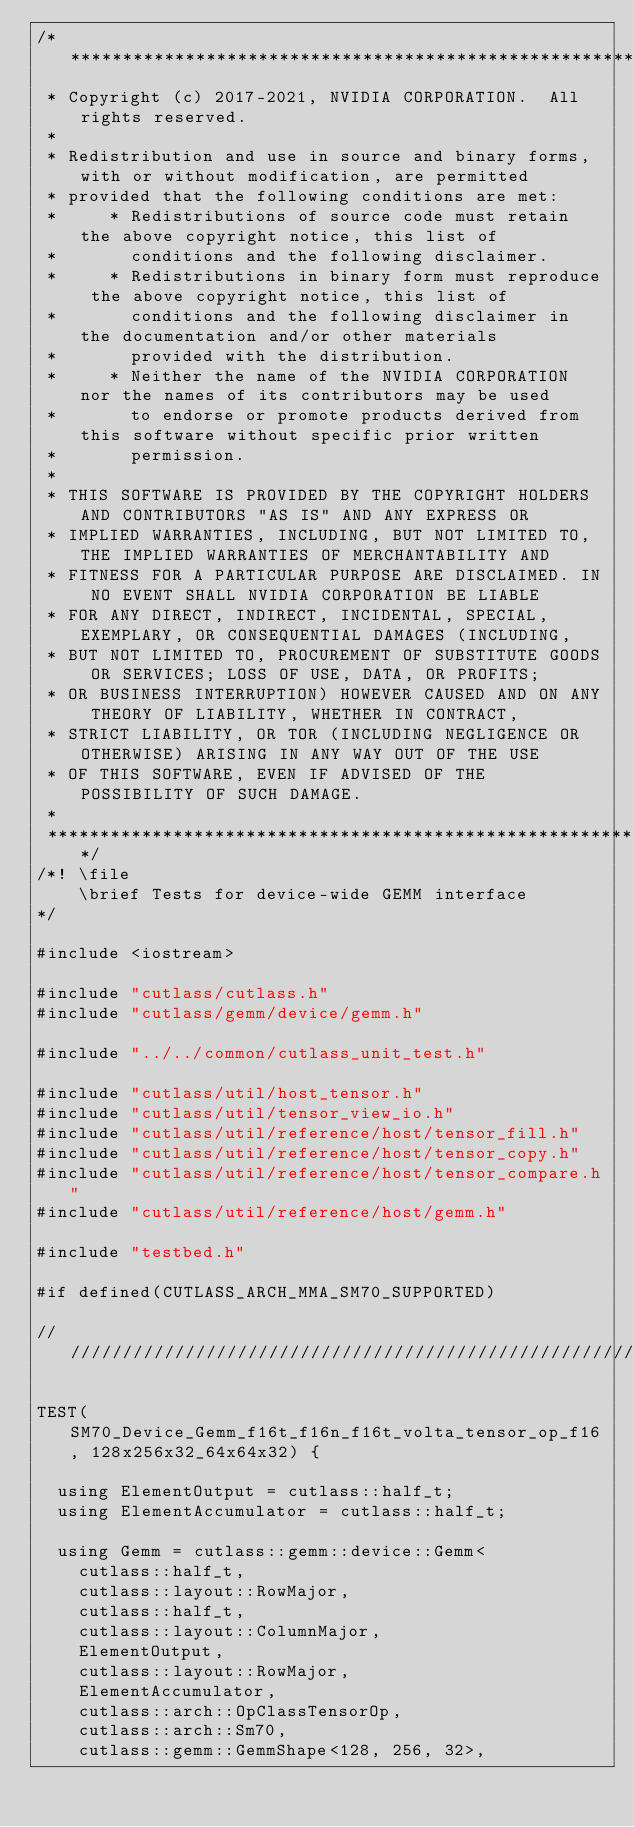<code> <loc_0><loc_0><loc_500><loc_500><_Cuda_>/***************************************************************************************************
 * Copyright (c) 2017-2021, NVIDIA CORPORATION.  All rights reserved.
 *
 * Redistribution and use in source and binary forms, with or without modification, are permitted
 * provided that the following conditions are met:
 *     * Redistributions of source code must retain the above copyright notice, this list of
 *       conditions and the following disclaimer.
 *     * Redistributions in binary form must reproduce the above copyright notice, this list of
 *       conditions and the following disclaimer in the documentation and/or other materials
 *       provided with the distribution.
 *     * Neither the name of the NVIDIA CORPORATION nor the names of its contributors may be used
 *       to endorse or promote products derived from this software without specific prior written
 *       permission.
 *
 * THIS SOFTWARE IS PROVIDED BY THE COPYRIGHT HOLDERS AND CONTRIBUTORS "AS IS" AND ANY EXPRESS OR
 * IMPLIED WARRANTIES, INCLUDING, BUT NOT LIMITED TO, THE IMPLIED WARRANTIES OF MERCHANTABILITY AND
 * FITNESS FOR A PARTICULAR PURPOSE ARE DISCLAIMED. IN NO EVENT SHALL NVIDIA CORPORATION BE LIABLE
 * FOR ANY DIRECT, INDIRECT, INCIDENTAL, SPECIAL, EXEMPLARY, OR CONSEQUENTIAL DAMAGES (INCLUDING,
 * BUT NOT LIMITED TO, PROCUREMENT OF SUBSTITUTE GOODS OR SERVICES; LOSS OF USE, DATA, OR PROFITS;
 * OR BUSINESS INTERRUPTION) HOWEVER CAUSED AND ON ANY THEORY OF LIABILITY, WHETHER IN CONTRACT,
 * STRICT LIABILITY, OR TOR (INCLUDING NEGLIGENCE OR OTHERWISE) ARISING IN ANY WAY OUT OF THE USE
 * OF THIS SOFTWARE, EVEN IF ADVISED OF THE POSSIBILITY OF SUCH DAMAGE.
 *
 **************************************************************************************************/
/*! \file
    \brief Tests for device-wide GEMM interface
*/

#include <iostream>

#include "cutlass/cutlass.h"
#include "cutlass/gemm/device/gemm.h"

#include "../../common/cutlass_unit_test.h"

#include "cutlass/util/host_tensor.h"
#include "cutlass/util/tensor_view_io.h"
#include "cutlass/util/reference/host/tensor_fill.h"
#include "cutlass/util/reference/host/tensor_copy.h"
#include "cutlass/util/reference/host/tensor_compare.h"
#include "cutlass/util/reference/host/gemm.h"

#include "testbed.h"

#if defined(CUTLASS_ARCH_MMA_SM70_SUPPORTED)

/////////////////////////////////////////////////////////////////////////////////////////////////

TEST(SM70_Device_Gemm_f16t_f16n_f16t_volta_tensor_op_f16, 128x256x32_64x64x32) {

  using ElementOutput = cutlass::half_t;
  using ElementAccumulator = cutlass::half_t;

  using Gemm = cutlass::gemm::device::Gemm<
    cutlass::half_t,
    cutlass::layout::RowMajor,
    cutlass::half_t,
    cutlass::layout::ColumnMajor,
    ElementOutput,
    cutlass::layout::RowMajor,
    ElementAccumulator,
    cutlass::arch::OpClassTensorOp,
    cutlass::arch::Sm70,
    cutlass::gemm::GemmShape<128, 256, 32>,</code> 